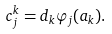<formula> <loc_0><loc_0><loc_500><loc_500>c _ { j } ^ { k } = d _ { k } \varphi _ { j } ( a _ { k } ) .</formula> 